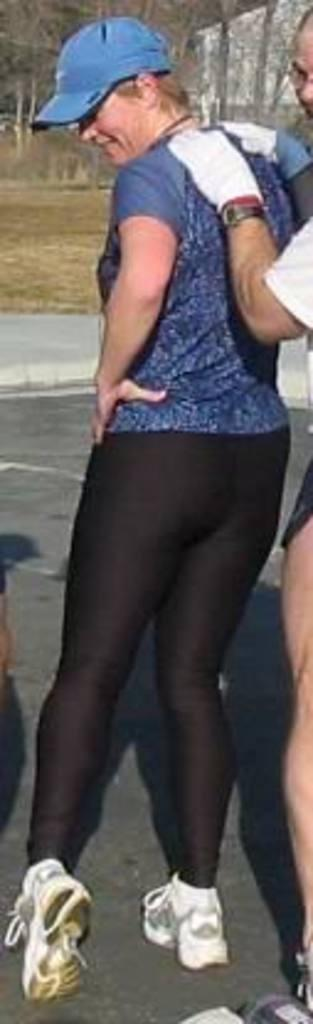Who or what can be seen in the image? There are people in the image. What structure is located on the right side of the image? There is a building on the right side of the image. What type of natural environment is visible in the background of the image? There are trees in the background of the image. What color is the cave in the image? There is no cave present in the image. 